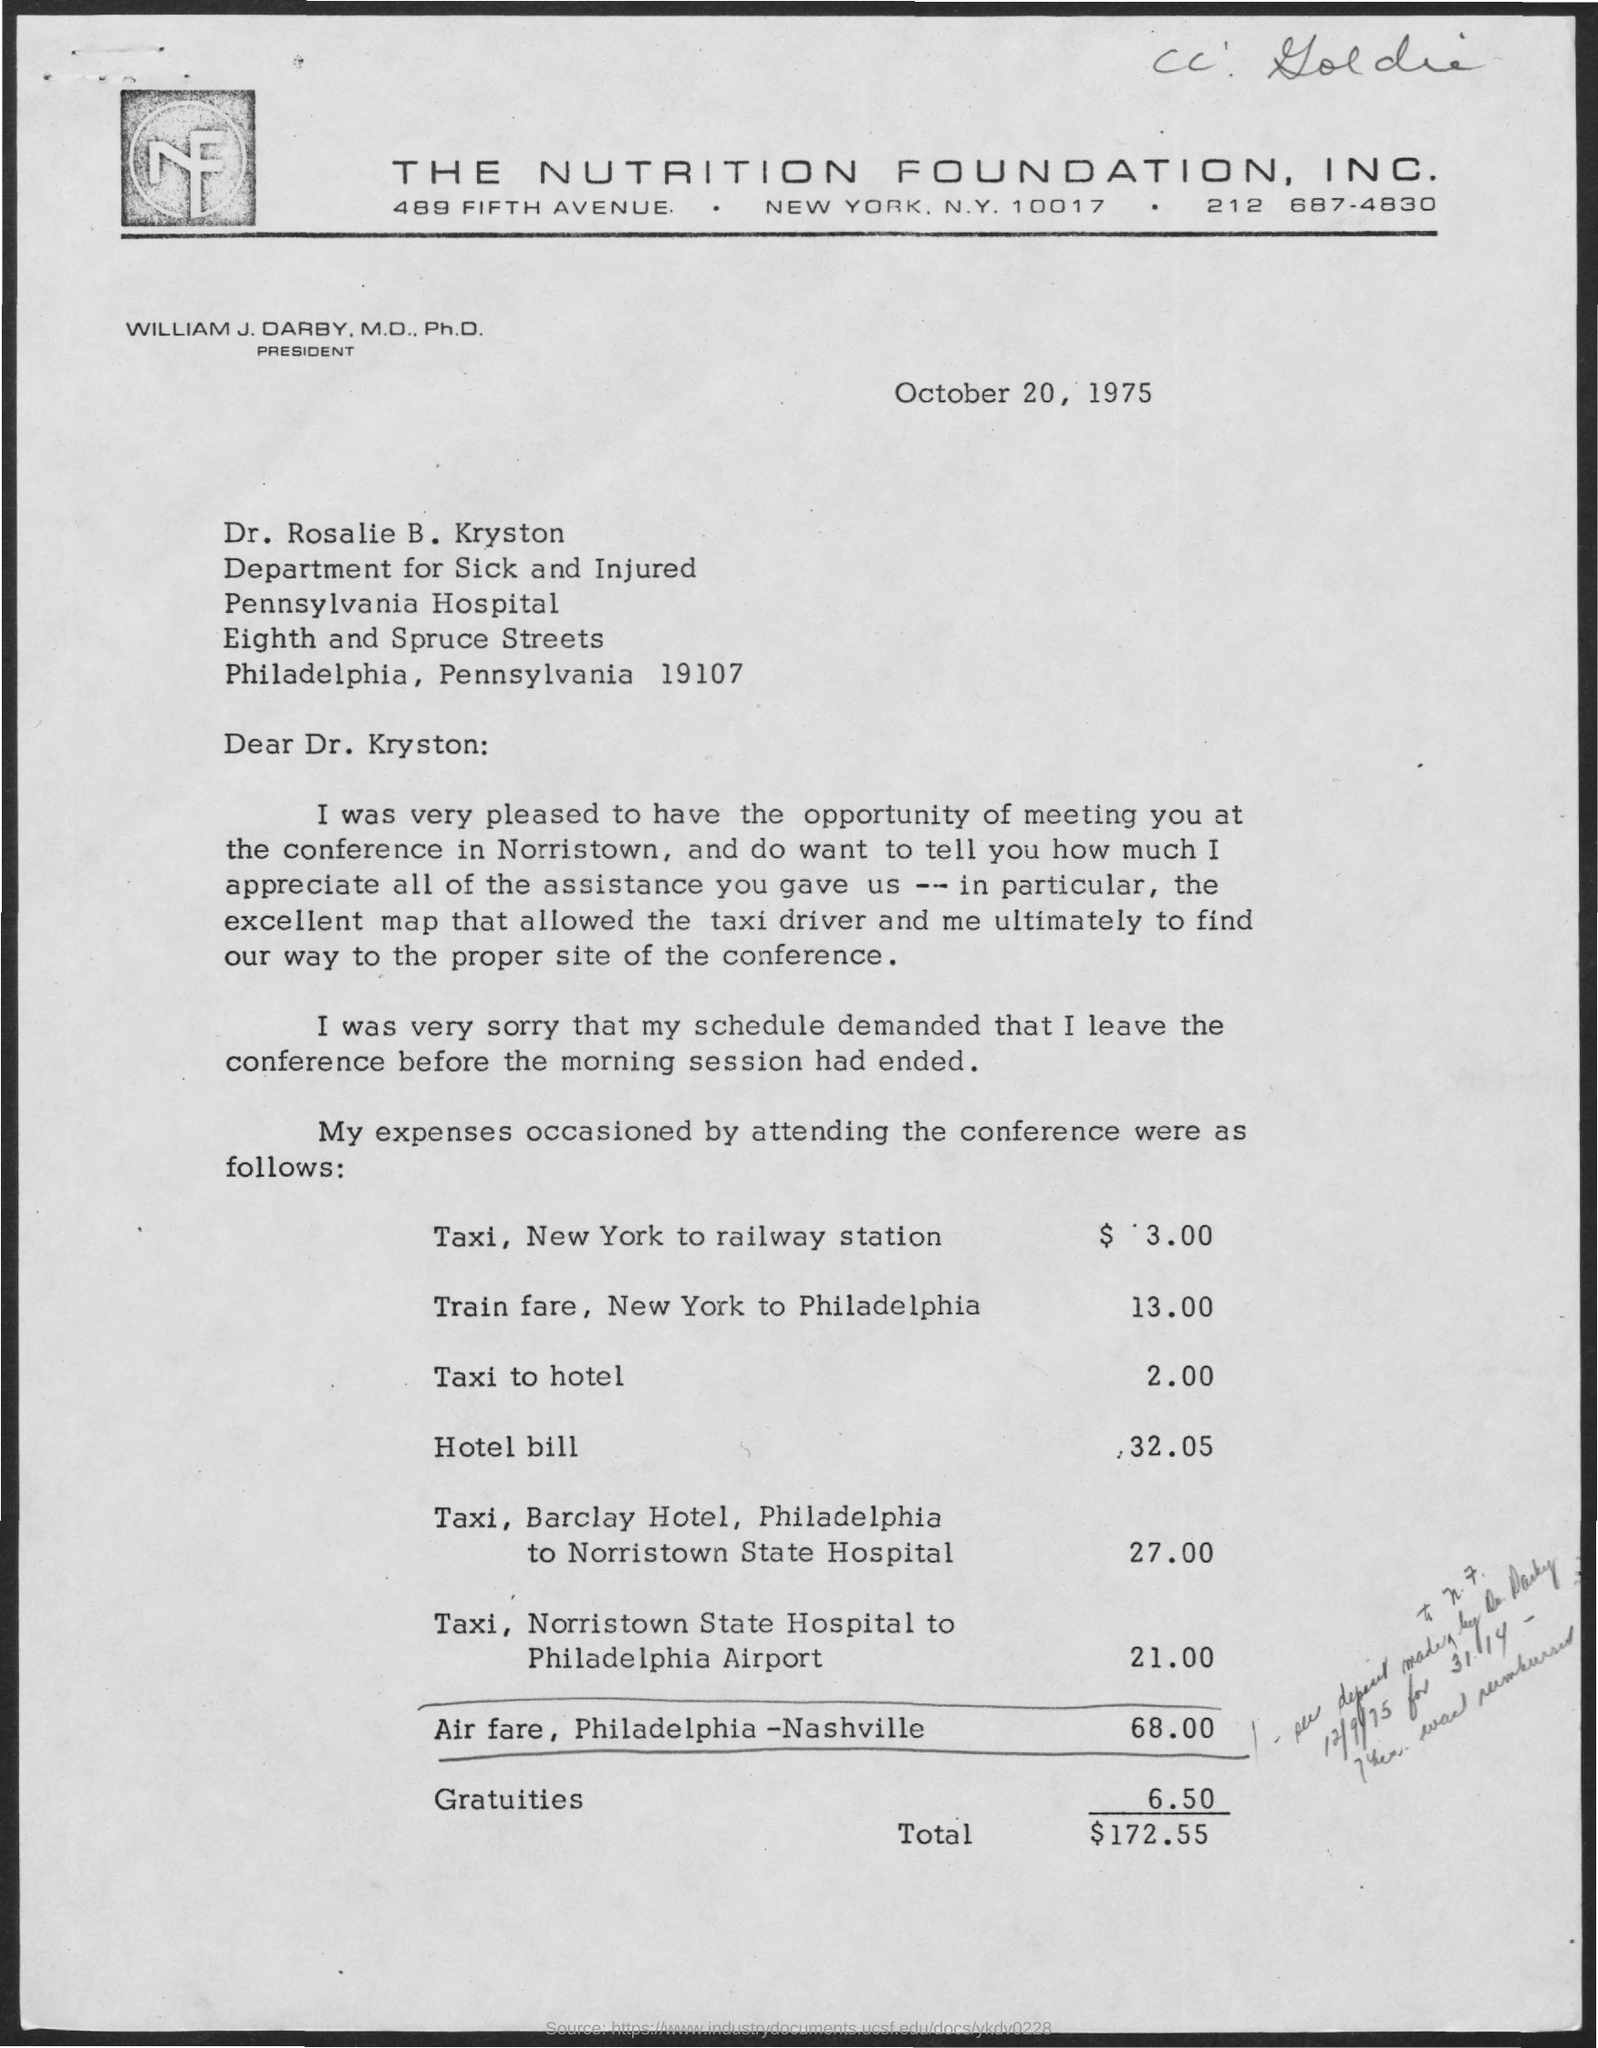What is written in the letter head ?
Give a very brief answer. THE NUTRITION FOUNDATION, INC. How much hotel bill ?
Provide a succinct answer. 32.05. When is the memorandum dated on ?
Your answer should be very brief. October 20, 1975. 